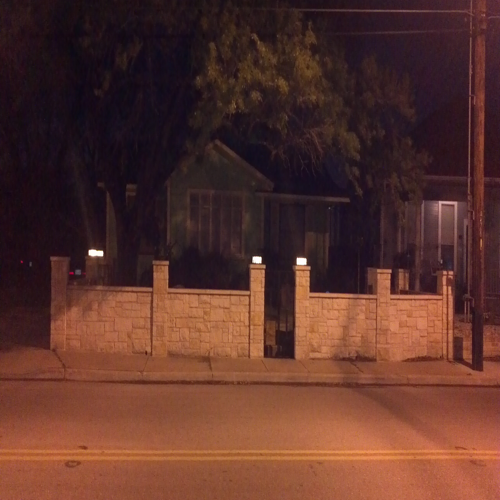What time of day does this image seem to have been taken? Based on the darkness and artificial lighting, it seems like the photo was taken at night. 